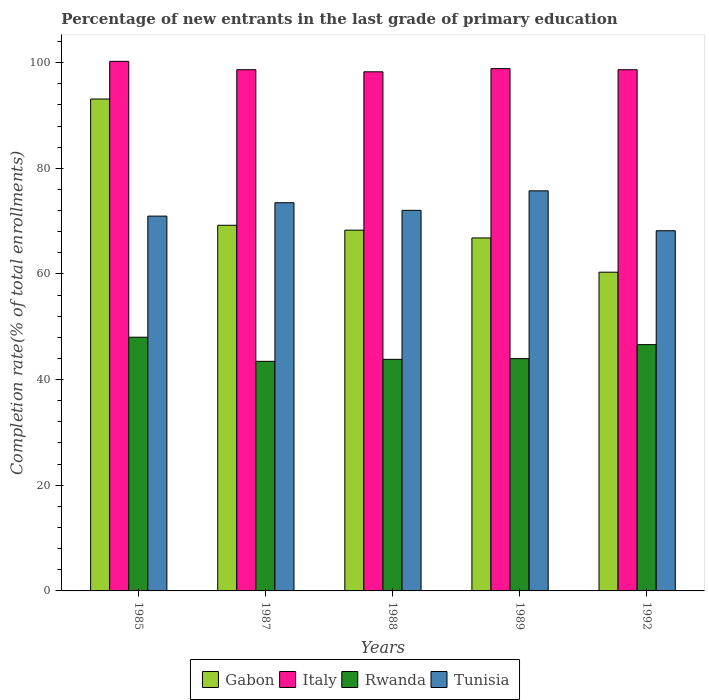How many groups of bars are there?
Give a very brief answer. 5. Are the number of bars per tick equal to the number of legend labels?
Your response must be concise. Yes. Are the number of bars on each tick of the X-axis equal?
Your answer should be very brief. Yes. How many bars are there on the 4th tick from the right?
Keep it short and to the point. 4. What is the percentage of new entrants in Italy in 1989?
Keep it short and to the point. 98.87. Across all years, what is the maximum percentage of new entrants in Italy?
Offer a terse response. 100.24. Across all years, what is the minimum percentage of new entrants in Rwanda?
Provide a succinct answer. 43.46. In which year was the percentage of new entrants in Italy maximum?
Provide a succinct answer. 1985. What is the total percentage of new entrants in Gabon in the graph?
Ensure brevity in your answer.  357.76. What is the difference between the percentage of new entrants in Italy in 1985 and that in 1988?
Offer a very short reply. 1.98. What is the difference between the percentage of new entrants in Gabon in 1988 and the percentage of new entrants in Italy in 1987?
Give a very brief answer. -30.37. What is the average percentage of new entrants in Tunisia per year?
Give a very brief answer. 72.08. In the year 1989, what is the difference between the percentage of new entrants in Rwanda and percentage of new entrants in Gabon?
Your response must be concise. -22.84. In how many years, is the percentage of new entrants in Gabon greater than 68 %?
Offer a very short reply. 3. What is the ratio of the percentage of new entrants in Gabon in 1985 to that in 1989?
Offer a terse response. 1.39. Is the difference between the percentage of new entrants in Rwanda in 1987 and 1992 greater than the difference between the percentage of new entrants in Gabon in 1987 and 1992?
Your answer should be very brief. No. What is the difference between the highest and the second highest percentage of new entrants in Rwanda?
Provide a succinct answer. 1.41. What is the difference between the highest and the lowest percentage of new entrants in Italy?
Give a very brief answer. 1.98. Is the sum of the percentage of new entrants in Italy in 1987 and 1989 greater than the maximum percentage of new entrants in Rwanda across all years?
Your response must be concise. Yes. What does the 1st bar from the left in 1988 represents?
Your answer should be compact. Gabon. What does the 3rd bar from the right in 1988 represents?
Your response must be concise. Italy. Are all the bars in the graph horizontal?
Give a very brief answer. No. How many years are there in the graph?
Give a very brief answer. 5. Does the graph contain any zero values?
Make the answer very short. No. Does the graph contain grids?
Make the answer very short. No. How many legend labels are there?
Provide a short and direct response. 4. How are the legend labels stacked?
Give a very brief answer. Horizontal. What is the title of the graph?
Your answer should be very brief. Percentage of new entrants in the last grade of primary education. Does "Kuwait" appear as one of the legend labels in the graph?
Keep it short and to the point. No. What is the label or title of the X-axis?
Offer a terse response. Years. What is the label or title of the Y-axis?
Offer a very short reply. Completion rate(% of total enrollments). What is the Completion rate(% of total enrollments) in Gabon in 1985?
Give a very brief answer. 93.11. What is the Completion rate(% of total enrollments) of Italy in 1985?
Provide a succinct answer. 100.24. What is the Completion rate(% of total enrollments) of Rwanda in 1985?
Your answer should be compact. 48.02. What is the Completion rate(% of total enrollments) of Tunisia in 1985?
Provide a succinct answer. 70.95. What is the Completion rate(% of total enrollments) in Gabon in 1987?
Provide a short and direct response. 69.21. What is the Completion rate(% of total enrollments) of Italy in 1987?
Provide a short and direct response. 98.66. What is the Completion rate(% of total enrollments) in Rwanda in 1987?
Offer a very short reply. 43.46. What is the Completion rate(% of total enrollments) in Tunisia in 1987?
Offer a terse response. 73.48. What is the Completion rate(% of total enrollments) of Gabon in 1988?
Provide a short and direct response. 68.29. What is the Completion rate(% of total enrollments) in Italy in 1988?
Offer a terse response. 98.26. What is the Completion rate(% of total enrollments) of Rwanda in 1988?
Your response must be concise. 43.84. What is the Completion rate(% of total enrollments) in Tunisia in 1988?
Keep it short and to the point. 72.04. What is the Completion rate(% of total enrollments) of Gabon in 1989?
Offer a very short reply. 66.81. What is the Completion rate(% of total enrollments) of Italy in 1989?
Provide a short and direct response. 98.87. What is the Completion rate(% of total enrollments) in Rwanda in 1989?
Provide a succinct answer. 43.97. What is the Completion rate(% of total enrollments) of Tunisia in 1989?
Your answer should be compact. 75.73. What is the Completion rate(% of total enrollments) in Gabon in 1992?
Give a very brief answer. 60.33. What is the Completion rate(% of total enrollments) in Italy in 1992?
Keep it short and to the point. 98.66. What is the Completion rate(% of total enrollments) in Rwanda in 1992?
Your answer should be very brief. 46.62. What is the Completion rate(% of total enrollments) of Tunisia in 1992?
Ensure brevity in your answer.  68.18. Across all years, what is the maximum Completion rate(% of total enrollments) of Gabon?
Give a very brief answer. 93.11. Across all years, what is the maximum Completion rate(% of total enrollments) in Italy?
Give a very brief answer. 100.24. Across all years, what is the maximum Completion rate(% of total enrollments) of Rwanda?
Your answer should be very brief. 48.02. Across all years, what is the maximum Completion rate(% of total enrollments) of Tunisia?
Keep it short and to the point. 75.73. Across all years, what is the minimum Completion rate(% of total enrollments) in Gabon?
Offer a terse response. 60.33. Across all years, what is the minimum Completion rate(% of total enrollments) of Italy?
Your answer should be compact. 98.26. Across all years, what is the minimum Completion rate(% of total enrollments) of Rwanda?
Keep it short and to the point. 43.46. Across all years, what is the minimum Completion rate(% of total enrollments) of Tunisia?
Your response must be concise. 68.18. What is the total Completion rate(% of total enrollments) in Gabon in the graph?
Provide a succinct answer. 357.76. What is the total Completion rate(% of total enrollments) in Italy in the graph?
Provide a succinct answer. 494.69. What is the total Completion rate(% of total enrollments) of Rwanda in the graph?
Your answer should be very brief. 225.9. What is the total Completion rate(% of total enrollments) in Tunisia in the graph?
Make the answer very short. 360.38. What is the difference between the Completion rate(% of total enrollments) of Gabon in 1985 and that in 1987?
Provide a succinct answer. 23.9. What is the difference between the Completion rate(% of total enrollments) in Italy in 1985 and that in 1987?
Your answer should be very brief. 1.58. What is the difference between the Completion rate(% of total enrollments) of Rwanda in 1985 and that in 1987?
Your answer should be very brief. 4.57. What is the difference between the Completion rate(% of total enrollments) of Tunisia in 1985 and that in 1987?
Ensure brevity in your answer.  -2.54. What is the difference between the Completion rate(% of total enrollments) of Gabon in 1985 and that in 1988?
Provide a short and direct response. 24.82. What is the difference between the Completion rate(% of total enrollments) in Italy in 1985 and that in 1988?
Make the answer very short. 1.98. What is the difference between the Completion rate(% of total enrollments) of Rwanda in 1985 and that in 1988?
Give a very brief answer. 4.19. What is the difference between the Completion rate(% of total enrollments) of Tunisia in 1985 and that in 1988?
Offer a terse response. -1.09. What is the difference between the Completion rate(% of total enrollments) in Gabon in 1985 and that in 1989?
Make the answer very short. 26.3. What is the difference between the Completion rate(% of total enrollments) in Italy in 1985 and that in 1989?
Offer a very short reply. 1.37. What is the difference between the Completion rate(% of total enrollments) of Rwanda in 1985 and that in 1989?
Make the answer very short. 4.05. What is the difference between the Completion rate(% of total enrollments) of Tunisia in 1985 and that in 1989?
Keep it short and to the point. -4.79. What is the difference between the Completion rate(% of total enrollments) of Gabon in 1985 and that in 1992?
Give a very brief answer. 32.78. What is the difference between the Completion rate(% of total enrollments) in Italy in 1985 and that in 1992?
Provide a short and direct response. 1.58. What is the difference between the Completion rate(% of total enrollments) of Rwanda in 1985 and that in 1992?
Your answer should be compact. 1.41. What is the difference between the Completion rate(% of total enrollments) in Tunisia in 1985 and that in 1992?
Ensure brevity in your answer.  2.77. What is the difference between the Completion rate(% of total enrollments) in Gabon in 1987 and that in 1988?
Your response must be concise. 0.93. What is the difference between the Completion rate(% of total enrollments) in Italy in 1987 and that in 1988?
Give a very brief answer. 0.4. What is the difference between the Completion rate(% of total enrollments) in Rwanda in 1987 and that in 1988?
Your response must be concise. -0.38. What is the difference between the Completion rate(% of total enrollments) in Tunisia in 1987 and that in 1988?
Your response must be concise. 1.44. What is the difference between the Completion rate(% of total enrollments) of Gabon in 1987 and that in 1989?
Keep it short and to the point. 2.4. What is the difference between the Completion rate(% of total enrollments) in Italy in 1987 and that in 1989?
Offer a terse response. -0.21. What is the difference between the Completion rate(% of total enrollments) of Rwanda in 1987 and that in 1989?
Provide a short and direct response. -0.51. What is the difference between the Completion rate(% of total enrollments) of Tunisia in 1987 and that in 1989?
Provide a short and direct response. -2.25. What is the difference between the Completion rate(% of total enrollments) in Gabon in 1987 and that in 1992?
Provide a succinct answer. 8.88. What is the difference between the Completion rate(% of total enrollments) of Italy in 1987 and that in 1992?
Offer a terse response. 0. What is the difference between the Completion rate(% of total enrollments) in Rwanda in 1987 and that in 1992?
Keep it short and to the point. -3.16. What is the difference between the Completion rate(% of total enrollments) of Tunisia in 1987 and that in 1992?
Make the answer very short. 5.3. What is the difference between the Completion rate(% of total enrollments) of Gabon in 1988 and that in 1989?
Your response must be concise. 1.47. What is the difference between the Completion rate(% of total enrollments) of Italy in 1988 and that in 1989?
Keep it short and to the point. -0.6. What is the difference between the Completion rate(% of total enrollments) of Rwanda in 1988 and that in 1989?
Provide a succinct answer. -0.13. What is the difference between the Completion rate(% of total enrollments) in Tunisia in 1988 and that in 1989?
Your answer should be compact. -3.69. What is the difference between the Completion rate(% of total enrollments) in Gabon in 1988 and that in 1992?
Offer a very short reply. 7.96. What is the difference between the Completion rate(% of total enrollments) of Italy in 1988 and that in 1992?
Your answer should be very brief. -0.4. What is the difference between the Completion rate(% of total enrollments) of Rwanda in 1988 and that in 1992?
Your answer should be very brief. -2.78. What is the difference between the Completion rate(% of total enrollments) in Tunisia in 1988 and that in 1992?
Keep it short and to the point. 3.86. What is the difference between the Completion rate(% of total enrollments) in Gabon in 1989 and that in 1992?
Give a very brief answer. 6.48. What is the difference between the Completion rate(% of total enrollments) of Italy in 1989 and that in 1992?
Make the answer very short. 0.21. What is the difference between the Completion rate(% of total enrollments) in Rwanda in 1989 and that in 1992?
Provide a succinct answer. -2.65. What is the difference between the Completion rate(% of total enrollments) of Tunisia in 1989 and that in 1992?
Offer a very short reply. 7.55. What is the difference between the Completion rate(% of total enrollments) of Gabon in 1985 and the Completion rate(% of total enrollments) of Italy in 1987?
Offer a very short reply. -5.55. What is the difference between the Completion rate(% of total enrollments) of Gabon in 1985 and the Completion rate(% of total enrollments) of Rwanda in 1987?
Offer a terse response. 49.65. What is the difference between the Completion rate(% of total enrollments) in Gabon in 1985 and the Completion rate(% of total enrollments) in Tunisia in 1987?
Provide a succinct answer. 19.63. What is the difference between the Completion rate(% of total enrollments) of Italy in 1985 and the Completion rate(% of total enrollments) of Rwanda in 1987?
Provide a succinct answer. 56.78. What is the difference between the Completion rate(% of total enrollments) in Italy in 1985 and the Completion rate(% of total enrollments) in Tunisia in 1987?
Provide a succinct answer. 26.76. What is the difference between the Completion rate(% of total enrollments) of Rwanda in 1985 and the Completion rate(% of total enrollments) of Tunisia in 1987?
Offer a very short reply. -25.46. What is the difference between the Completion rate(% of total enrollments) of Gabon in 1985 and the Completion rate(% of total enrollments) of Italy in 1988?
Provide a succinct answer. -5.15. What is the difference between the Completion rate(% of total enrollments) in Gabon in 1985 and the Completion rate(% of total enrollments) in Rwanda in 1988?
Provide a short and direct response. 49.27. What is the difference between the Completion rate(% of total enrollments) in Gabon in 1985 and the Completion rate(% of total enrollments) in Tunisia in 1988?
Provide a short and direct response. 21.07. What is the difference between the Completion rate(% of total enrollments) in Italy in 1985 and the Completion rate(% of total enrollments) in Rwanda in 1988?
Give a very brief answer. 56.4. What is the difference between the Completion rate(% of total enrollments) of Italy in 1985 and the Completion rate(% of total enrollments) of Tunisia in 1988?
Keep it short and to the point. 28.2. What is the difference between the Completion rate(% of total enrollments) of Rwanda in 1985 and the Completion rate(% of total enrollments) of Tunisia in 1988?
Offer a very short reply. -24.01. What is the difference between the Completion rate(% of total enrollments) of Gabon in 1985 and the Completion rate(% of total enrollments) of Italy in 1989?
Offer a very short reply. -5.76. What is the difference between the Completion rate(% of total enrollments) in Gabon in 1985 and the Completion rate(% of total enrollments) in Rwanda in 1989?
Offer a very short reply. 49.14. What is the difference between the Completion rate(% of total enrollments) of Gabon in 1985 and the Completion rate(% of total enrollments) of Tunisia in 1989?
Give a very brief answer. 17.38. What is the difference between the Completion rate(% of total enrollments) of Italy in 1985 and the Completion rate(% of total enrollments) of Rwanda in 1989?
Make the answer very short. 56.27. What is the difference between the Completion rate(% of total enrollments) in Italy in 1985 and the Completion rate(% of total enrollments) in Tunisia in 1989?
Your answer should be very brief. 24.51. What is the difference between the Completion rate(% of total enrollments) of Rwanda in 1985 and the Completion rate(% of total enrollments) of Tunisia in 1989?
Give a very brief answer. -27.71. What is the difference between the Completion rate(% of total enrollments) in Gabon in 1985 and the Completion rate(% of total enrollments) in Italy in 1992?
Offer a very short reply. -5.55. What is the difference between the Completion rate(% of total enrollments) of Gabon in 1985 and the Completion rate(% of total enrollments) of Rwanda in 1992?
Make the answer very short. 46.5. What is the difference between the Completion rate(% of total enrollments) of Gabon in 1985 and the Completion rate(% of total enrollments) of Tunisia in 1992?
Offer a very short reply. 24.93. What is the difference between the Completion rate(% of total enrollments) in Italy in 1985 and the Completion rate(% of total enrollments) in Rwanda in 1992?
Your answer should be very brief. 53.63. What is the difference between the Completion rate(% of total enrollments) of Italy in 1985 and the Completion rate(% of total enrollments) of Tunisia in 1992?
Your answer should be compact. 32.06. What is the difference between the Completion rate(% of total enrollments) of Rwanda in 1985 and the Completion rate(% of total enrollments) of Tunisia in 1992?
Ensure brevity in your answer.  -20.16. What is the difference between the Completion rate(% of total enrollments) in Gabon in 1987 and the Completion rate(% of total enrollments) in Italy in 1988?
Offer a very short reply. -29.05. What is the difference between the Completion rate(% of total enrollments) in Gabon in 1987 and the Completion rate(% of total enrollments) in Rwanda in 1988?
Your answer should be compact. 25.38. What is the difference between the Completion rate(% of total enrollments) in Gabon in 1987 and the Completion rate(% of total enrollments) in Tunisia in 1988?
Your answer should be compact. -2.82. What is the difference between the Completion rate(% of total enrollments) of Italy in 1987 and the Completion rate(% of total enrollments) of Rwanda in 1988?
Provide a short and direct response. 54.82. What is the difference between the Completion rate(% of total enrollments) of Italy in 1987 and the Completion rate(% of total enrollments) of Tunisia in 1988?
Give a very brief answer. 26.62. What is the difference between the Completion rate(% of total enrollments) of Rwanda in 1987 and the Completion rate(% of total enrollments) of Tunisia in 1988?
Keep it short and to the point. -28.58. What is the difference between the Completion rate(% of total enrollments) of Gabon in 1987 and the Completion rate(% of total enrollments) of Italy in 1989?
Provide a succinct answer. -29.65. What is the difference between the Completion rate(% of total enrollments) in Gabon in 1987 and the Completion rate(% of total enrollments) in Rwanda in 1989?
Provide a succinct answer. 25.24. What is the difference between the Completion rate(% of total enrollments) in Gabon in 1987 and the Completion rate(% of total enrollments) in Tunisia in 1989?
Your response must be concise. -6.52. What is the difference between the Completion rate(% of total enrollments) of Italy in 1987 and the Completion rate(% of total enrollments) of Rwanda in 1989?
Keep it short and to the point. 54.69. What is the difference between the Completion rate(% of total enrollments) of Italy in 1987 and the Completion rate(% of total enrollments) of Tunisia in 1989?
Your response must be concise. 22.93. What is the difference between the Completion rate(% of total enrollments) in Rwanda in 1987 and the Completion rate(% of total enrollments) in Tunisia in 1989?
Keep it short and to the point. -32.28. What is the difference between the Completion rate(% of total enrollments) of Gabon in 1987 and the Completion rate(% of total enrollments) of Italy in 1992?
Provide a short and direct response. -29.44. What is the difference between the Completion rate(% of total enrollments) of Gabon in 1987 and the Completion rate(% of total enrollments) of Rwanda in 1992?
Offer a terse response. 22.6. What is the difference between the Completion rate(% of total enrollments) of Gabon in 1987 and the Completion rate(% of total enrollments) of Tunisia in 1992?
Ensure brevity in your answer.  1.03. What is the difference between the Completion rate(% of total enrollments) of Italy in 1987 and the Completion rate(% of total enrollments) of Rwanda in 1992?
Provide a succinct answer. 52.04. What is the difference between the Completion rate(% of total enrollments) in Italy in 1987 and the Completion rate(% of total enrollments) in Tunisia in 1992?
Your answer should be very brief. 30.48. What is the difference between the Completion rate(% of total enrollments) of Rwanda in 1987 and the Completion rate(% of total enrollments) of Tunisia in 1992?
Offer a very short reply. -24.72. What is the difference between the Completion rate(% of total enrollments) of Gabon in 1988 and the Completion rate(% of total enrollments) of Italy in 1989?
Give a very brief answer. -30.58. What is the difference between the Completion rate(% of total enrollments) of Gabon in 1988 and the Completion rate(% of total enrollments) of Rwanda in 1989?
Provide a succinct answer. 24.32. What is the difference between the Completion rate(% of total enrollments) in Gabon in 1988 and the Completion rate(% of total enrollments) in Tunisia in 1989?
Your response must be concise. -7.45. What is the difference between the Completion rate(% of total enrollments) of Italy in 1988 and the Completion rate(% of total enrollments) of Rwanda in 1989?
Give a very brief answer. 54.29. What is the difference between the Completion rate(% of total enrollments) of Italy in 1988 and the Completion rate(% of total enrollments) of Tunisia in 1989?
Keep it short and to the point. 22.53. What is the difference between the Completion rate(% of total enrollments) in Rwanda in 1988 and the Completion rate(% of total enrollments) in Tunisia in 1989?
Provide a succinct answer. -31.9. What is the difference between the Completion rate(% of total enrollments) of Gabon in 1988 and the Completion rate(% of total enrollments) of Italy in 1992?
Your answer should be compact. -30.37. What is the difference between the Completion rate(% of total enrollments) in Gabon in 1988 and the Completion rate(% of total enrollments) in Rwanda in 1992?
Make the answer very short. 21.67. What is the difference between the Completion rate(% of total enrollments) of Gabon in 1988 and the Completion rate(% of total enrollments) of Tunisia in 1992?
Provide a succinct answer. 0.11. What is the difference between the Completion rate(% of total enrollments) in Italy in 1988 and the Completion rate(% of total enrollments) in Rwanda in 1992?
Your response must be concise. 51.65. What is the difference between the Completion rate(% of total enrollments) in Italy in 1988 and the Completion rate(% of total enrollments) in Tunisia in 1992?
Provide a succinct answer. 30.08. What is the difference between the Completion rate(% of total enrollments) in Rwanda in 1988 and the Completion rate(% of total enrollments) in Tunisia in 1992?
Ensure brevity in your answer.  -24.34. What is the difference between the Completion rate(% of total enrollments) of Gabon in 1989 and the Completion rate(% of total enrollments) of Italy in 1992?
Provide a short and direct response. -31.85. What is the difference between the Completion rate(% of total enrollments) in Gabon in 1989 and the Completion rate(% of total enrollments) in Rwanda in 1992?
Provide a succinct answer. 20.2. What is the difference between the Completion rate(% of total enrollments) in Gabon in 1989 and the Completion rate(% of total enrollments) in Tunisia in 1992?
Ensure brevity in your answer.  -1.37. What is the difference between the Completion rate(% of total enrollments) of Italy in 1989 and the Completion rate(% of total enrollments) of Rwanda in 1992?
Make the answer very short. 52.25. What is the difference between the Completion rate(% of total enrollments) of Italy in 1989 and the Completion rate(% of total enrollments) of Tunisia in 1992?
Provide a short and direct response. 30.69. What is the difference between the Completion rate(% of total enrollments) of Rwanda in 1989 and the Completion rate(% of total enrollments) of Tunisia in 1992?
Offer a terse response. -24.21. What is the average Completion rate(% of total enrollments) in Gabon per year?
Your response must be concise. 71.55. What is the average Completion rate(% of total enrollments) of Italy per year?
Your answer should be very brief. 98.94. What is the average Completion rate(% of total enrollments) of Rwanda per year?
Your answer should be very brief. 45.18. What is the average Completion rate(% of total enrollments) of Tunisia per year?
Offer a terse response. 72.08. In the year 1985, what is the difference between the Completion rate(% of total enrollments) in Gabon and Completion rate(% of total enrollments) in Italy?
Offer a terse response. -7.13. In the year 1985, what is the difference between the Completion rate(% of total enrollments) of Gabon and Completion rate(% of total enrollments) of Rwanda?
Provide a succinct answer. 45.09. In the year 1985, what is the difference between the Completion rate(% of total enrollments) in Gabon and Completion rate(% of total enrollments) in Tunisia?
Keep it short and to the point. 22.16. In the year 1985, what is the difference between the Completion rate(% of total enrollments) in Italy and Completion rate(% of total enrollments) in Rwanda?
Provide a short and direct response. 52.22. In the year 1985, what is the difference between the Completion rate(% of total enrollments) in Italy and Completion rate(% of total enrollments) in Tunisia?
Provide a short and direct response. 29.29. In the year 1985, what is the difference between the Completion rate(% of total enrollments) of Rwanda and Completion rate(% of total enrollments) of Tunisia?
Your answer should be very brief. -22.92. In the year 1987, what is the difference between the Completion rate(% of total enrollments) of Gabon and Completion rate(% of total enrollments) of Italy?
Offer a terse response. -29.45. In the year 1987, what is the difference between the Completion rate(% of total enrollments) of Gabon and Completion rate(% of total enrollments) of Rwanda?
Your response must be concise. 25.76. In the year 1987, what is the difference between the Completion rate(% of total enrollments) of Gabon and Completion rate(% of total enrollments) of Tunisia?
Your response must be concise. -4.27. In the year 1987, what is the difference between the Completion rate(% of total enrollments) in Italy and Completion rate(% of total enrollments) in Rwanda?
Offer a very short reply. 55.2. In the year 1987, what is the difference between the Completion rate(% of total enrollments) of Italy and Completion rate(% of total enrollments) of Tunisia?
Your response must be concise. 25.18. In the year 1987, what is the difference between the Completion rate(% of total enrollments) in Rwanda and Completion rate(% of total enrollments) in Tunisia?
Your response must be concise. -30.02. In the year 1988, what is the difference between the Completion rate(% of total enrollments) of Gabon and Completion rate(% of total enrollments) of Italy?
Offer a terse response. -29.97. In the year 1988, what is the difference between the Completion rate(% of total enrollments) of Gabon and Completion rate(% of total enrollments) of Rwanda?
Your response must be concise. 24.45. In the year 1988, what is the difference between the Completion rate(% of total enrollments) of Gabon and Completion rate(% of total enrollments) of Tunisia?
Your answer should be very brief. -3.75. In the year 1988, what is the difference between the Completion rate(% of total enrollments) in Italy and Completion rate(% of total enrollments) in Rwanda?
Your answer should be very brief. 54.42. In the year 1988, what is the difference between the Completion rate(% of total enrollments) of Italy and Completion rate(% of total enrollments) of Tunisia?
Keep it short and to the point. 26.22. In the year 1988, what is the difference between the Completion rate(% of total enrollments) in Rwanda and Completion rate(% of total enrollments) in Tunisia?
Your answer should be very brief. -28.2. In the year 1989, what is the difference between the Completion rate(% of total enrollments) of Gabon and Completion rate(% of total enrollments) of Italy?
Offer a very short reply. -32.05. In the year 1989, what is the difference between the Completion rate(% of total enrollments) in Gabon and Completion rate(% of total enrollments) in Rwanda?
Your answer should be compact. 22.84. In the year 1989, what is the difference between the Completion rate(% of total enrollments) of Gabon and Completion rate(% of total enrollments) of Tunisia?
Make the answer very short. -8.92. In the year 1989, what is the difference between the Completion rate(% of total enrollments) in Italy and Completion rate(% of total enrollments) in Rwanda?
Your answer should be very brief. 54.9. In the year 1989, what is the difference between the Completion rate(% of total enrollments) of Italy and Completion rate(% of total enrollments) of Tunisia?
Keep it short and to the point. 23.13. In the year 1989, what is the difference between the Completion rate(% of total enrollments) of Rwanda and Completion rate(% of total enrollments) of Tunisia?
Provide a succinct answer. -31.76. In the year 1992, what is the difference between the Completion rate(% of total enrollments) of Gabon and Completion rate(% of total enrollments) of Italy?
Ensure brevity in your answer.  -38.33. In the year 1992, what is the difference between the Completion rate(% of total enrollments) in Gabon and Completion rate(% of total enrollments) in Rwanda?
Make the answer very short. 13.72. In the year 1992, what is the difference between the Completion rate(% of total enrollments) of Gabon and Completion rate(% of total enrollments) of Tunisia?
Offer a terse response. -7.85. In the year 1992, what is the difference between the Completion rate(% of total enrollments) of Italy and Completion rate(% of total enrollments) of Rwanda?
Provide a succinct answer. 52.04. In the year 1992, what is the difference between the Completion rate(% of total enrollments) in Italy and Completion rate(% of total enrollments) in Tunisia?
Ensure brevity in your answer.  30.48. In the year 1992, what is the difference between the Completion rate(% of total enrollments) of Rwanda and Completion rate(% of total enrollments) of Tunisia?
Keep it short and to the point. -21.56. What is the ratio of the Completion rate(% of total enrollments) in Gabon in 1985 to that in 1987?
Offer a very short reply. 1.35. What is the ratio of the Completion rate(% of total enrollments) of Italy in 1985 to that in 1987?
Your answer should be compact. 1.02. What is the ratio of the Completion rate(% of total enrollments) of Rwanda in 1985 to that in 1987?
Your answer should be compact. 1.11. What is the ratio of the Completion rate(% of total enrollments) of Tunisia in 1985 to that in 1987?
Your answer should be very brief. 0.97. What is the ratio of the Completion rate(% of total enrollments) of Gabon in 1985 to that in 1988?
Your answer should be compact. 1.36. What is the ratio of the Completion rate(% of total enrollments) of Italy in 1985 to that in 1988?
Your response must be concise. 1.02. What is the ratio of the Completion rate(% of total enrollments) of Rwanda in 1985 to that in 1988?
Offer a terse response. 1.1. What is the ratio of the Completion rate(% of total enrollments) in Tunisia in 1985 to that in 1988?
Provide a short and direct response. 0.98. What is the ratio of the Completion rate(% of total enrollments) in Gabon in 1985 to that in 1989?
Give a very brief answer. 1.39. What is the ratio of the Completion rate(% of total enrollments) in Italy in 1985 to that in 1989?
Your answer should be compact. 1.01. What is the ratio of the Completion rate(% of total enrollments) in Rwanda in 1985 to that in 1989?
Offer a very short reply. 1.09. What is the ratio of the Completion rate(% of total enrollments) in Tunisia in 1985 to that in 1989?
Make the answer very short. 0.94. What is the ratio of the Completion rate(% of total enrollments) of Gabon in 1985 to that in 1992?
Offer a very short reply. 1.54. What is the ratio of the Completion rate(% of total enrollments) in Rwanda in 1985 to that in 1992?
Your response must be concise. 1.03. What is the ratio of the Completion rate(% of total enrollments) in Tunisia in 1985 to that in 1992?
Provide a succinct answer. 1.04. What is the ratio of the Completion rate(% of total enrollments) of Gabon in 1987 to that in 1988?
Give a very brief answer. 1.01. What is the ratio of the Completion rate(% of total enrollments) in Tunisia in 1987 to that in 1988?
Make the answer very short. 1.02. What is the ratio of the Completion rate(% of total enrollments) in Gabon in 1987 to that in 1989?
Your response must be concise. 1.04. What is the ratio of the Completion rate(% of total enrollments) of Rwanda in 1987 to that in 1989?
Keep it short and to the point. 0.99. What is the ratio of the Completion rate(% of total enrollments) in Tunisia in 1987 to that in 1989?
Make the answer very short. 0.97. What is the ratio of the Completion rate(% of total enrollments) of Gabon in 1987 to that in 1992?
Your answer should be compact. 1.15. What is the ratio of the Completion rate(% of total enrollments) of Rwanda in 1987 to that in 1992?
Your response must be concise. 0.93. What is the ratio of the Completion rate(% of total enrollments) of Tunisia in 1987 to that in 1992?
Provide a succinct answer. 1.08. What is the ratio of the Completion rate(% of total enrollments) in Gabon in 1988 to that in 1989?
Your response must be concise. 1.02. What is the ratio of the Completion rate(% of total enrollments) of Rwanda in 1988 to that in 1989?
Give a very brief answer. 1. What is the ratio of the Completion rate(% of total enrollments) of Tunisia in 1988 to that in 1989?
Keep it short and to the point. 0.95. What is the ratio of the Completion rate(% of total enrollments) in Gabon in 1988 to that in 1992?
Make the answer very short. 1.13. What is the ratio of the Completion rate(% of total enrollments) in Italy in 1988 to that in 1992?
Make the answer very short. 1. What is the ratio of the Completion rate(% of total enrollments) of Rwanda in 1988 to that in 1992?
Ensure brevity in your answer.  0.94. What is the ratio of the Completion rate(% of total enrollments) in Tunisia in 1988 to that in 1992?
Keep it short and to the point. 1.06. What is the ratio of the Completion rate(% of total enrollments) in Gabon in 1989 to that in 1992?
Your answer should be compact. 1.11. What is the ratio of the Completion rate(% of total enrollments) of Italy in 1989 to that in 1992?
Keep it short and to the point. 1. What is the ratio of the Completion rate(% of total enrollments) in Rwanda in 1989 to that in 1992?
Provide a succinct answer. 0.94. What is the ratio of the Completion rate(% of total enrollments) in Tunisia in 1989 to that in 1992?
Give a very brief answer. 1.11. What is the difference between the highest and the second highest Completion rate(% of total enrollments) of Gabon?
Your answer should be compact. 23.9. What is the difference between the highest and the second highest Completion rate(% of total enrollments) of Italy?
Offer a very short reply. 1.37. What is the difference between the highest and the second highest Completion rate(% of total enrollments) in Rwanda?
Your answer should be very brief. 1.41. What is the difference between the highest and the second highest Completion rate(% of total enrollments) in Tunisia?
Your answer should be very brief. 2.25. What is the difference between the highest and the lowest Completion rate(% of total enrollments) of Gabon?
Provide a short and direct response. 32.78. What is the difference between the highest and the lowest Completion rate(% of total enrollments) of Italy?
Make the answer very short. 1.98. What is the difference between the highest and the lowest Completion rate(% of total enrollments) in Rwanda?
Offer a very short reply. 4.57. What is the difference between the highest and the lowest Completion rate(% of total enrollments) in Tunisia?
Provide a succinct answer. 7.55. 